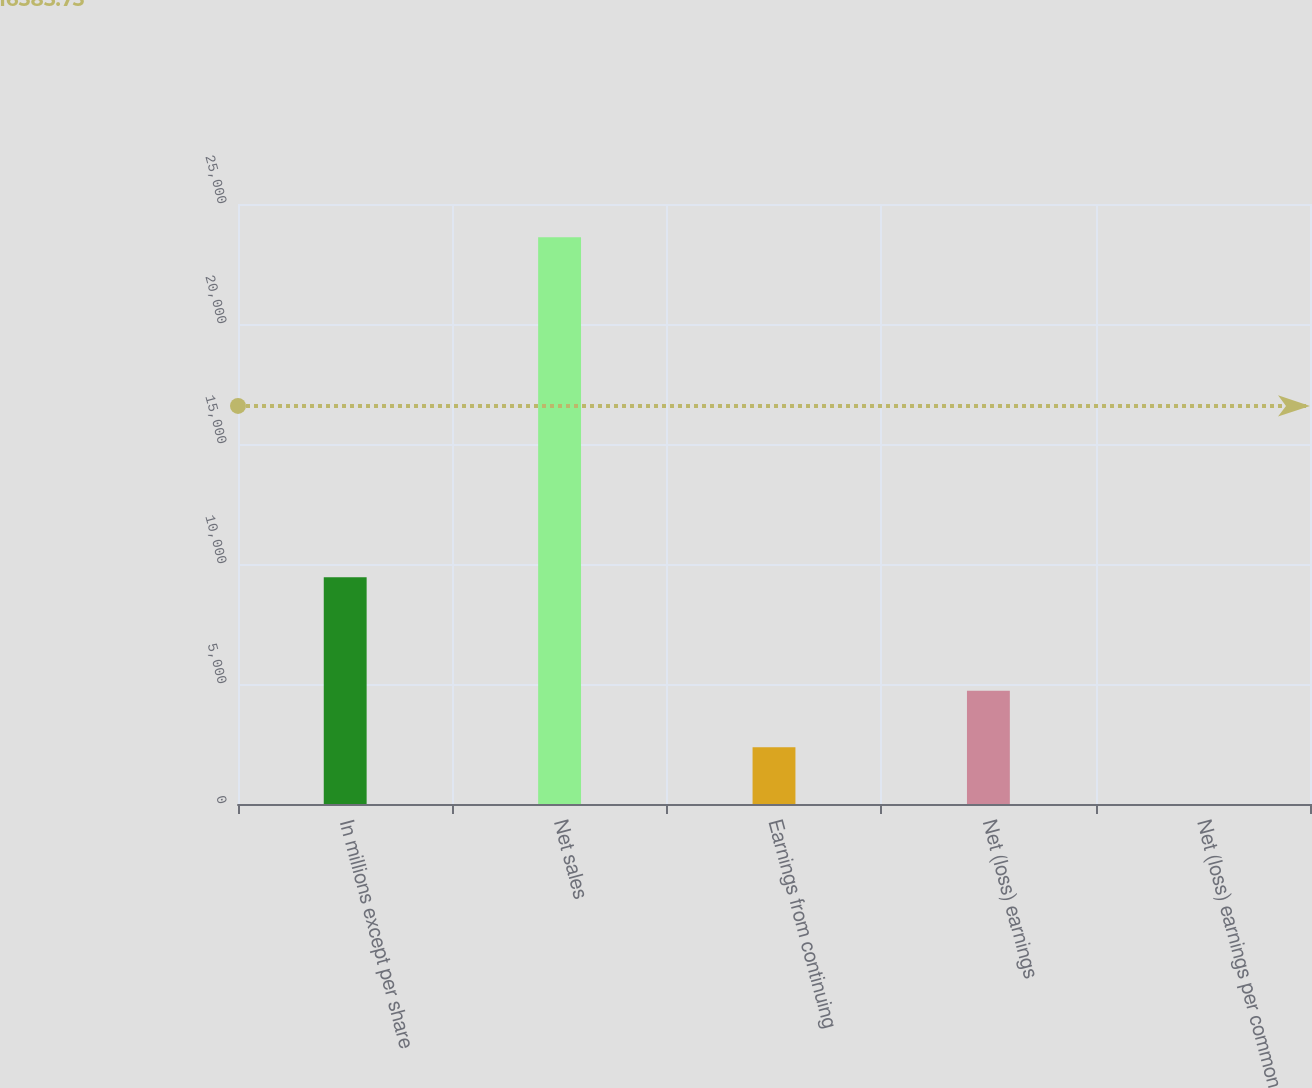<chart> <loc_0><loc_0><loc_500><loc_500><bar_chart><fcel>In millions except per share<fcel>Net sales<fcel>Earnings from continuing<fcel>Net (loss) earnings<fcel>Net (loss) earnings per common<nl><fcel>9445.22<fcel>23613<fcel>2361.35<fcel>4722.64<fcel>0.06<nl></chart> 